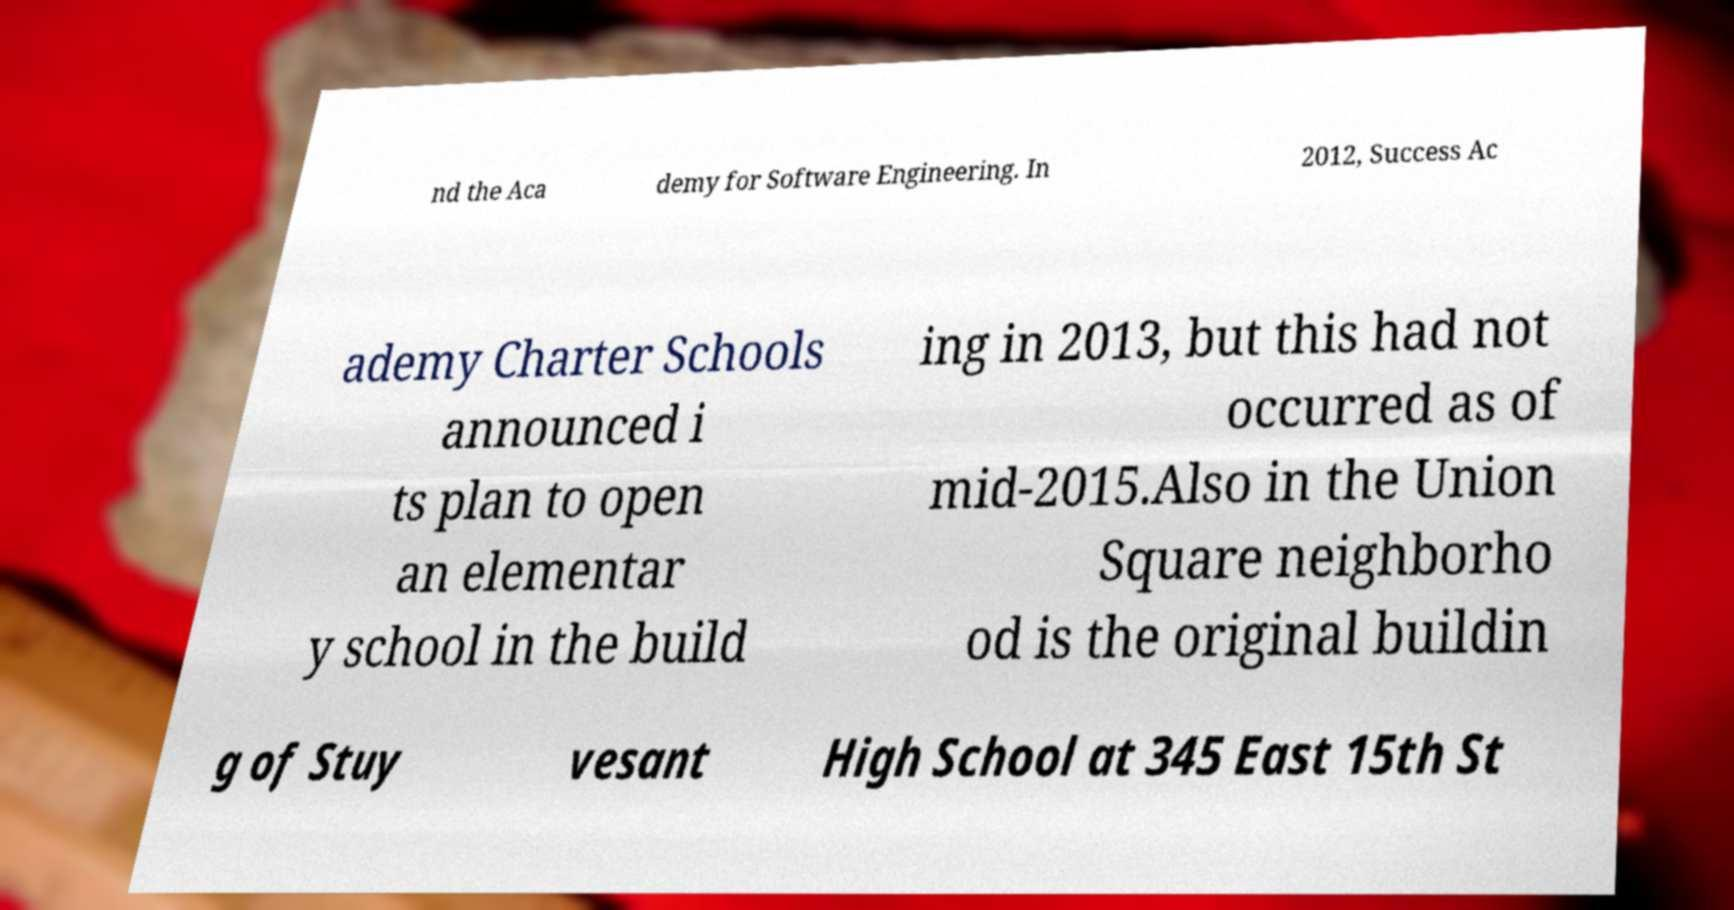Could you extract and type out the text from this image? nd the Aca demy for Software Engineering. In 2012, Success Ac ademy Charter Schools announced i ts plan to open an elementar y school in the build ing in 2013, but this had not occurred as of mid-2015.Also in the Union Square neighborho od is the original buildin g of Stuy vesant High School at 345 East 15th St 